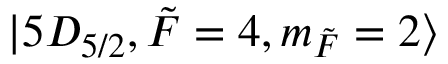Convert formula to latex. <formula><loc_0><loc_0><loc_500><loc_500>| 5 D _ { 5 / 2 } , \tilde { F } = 4 , m _ { \tilde { F } } = 2 \rangle</formula> 